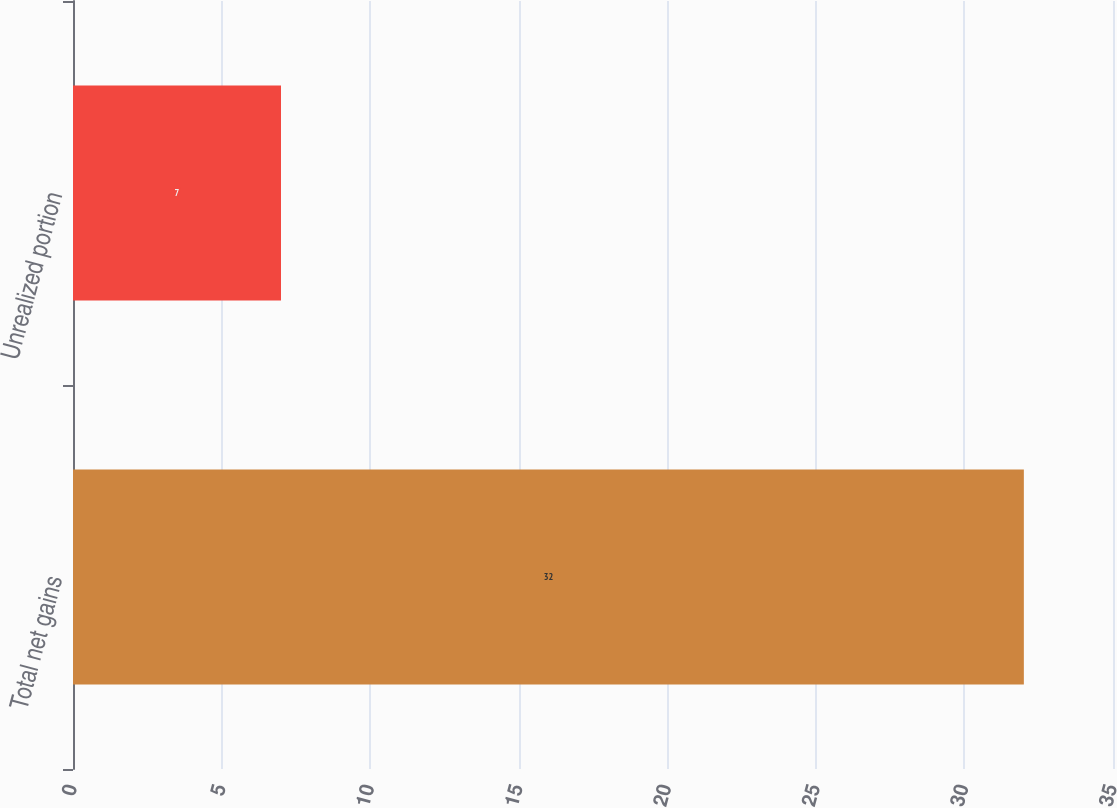Convert chart. <chart><loc_0><loc_0><loc_500><loc_500><bar_chart><fcel>Total net gains<fcel>Unrealized portion<nl><fcel>32<fcel>7<nl></chart> 